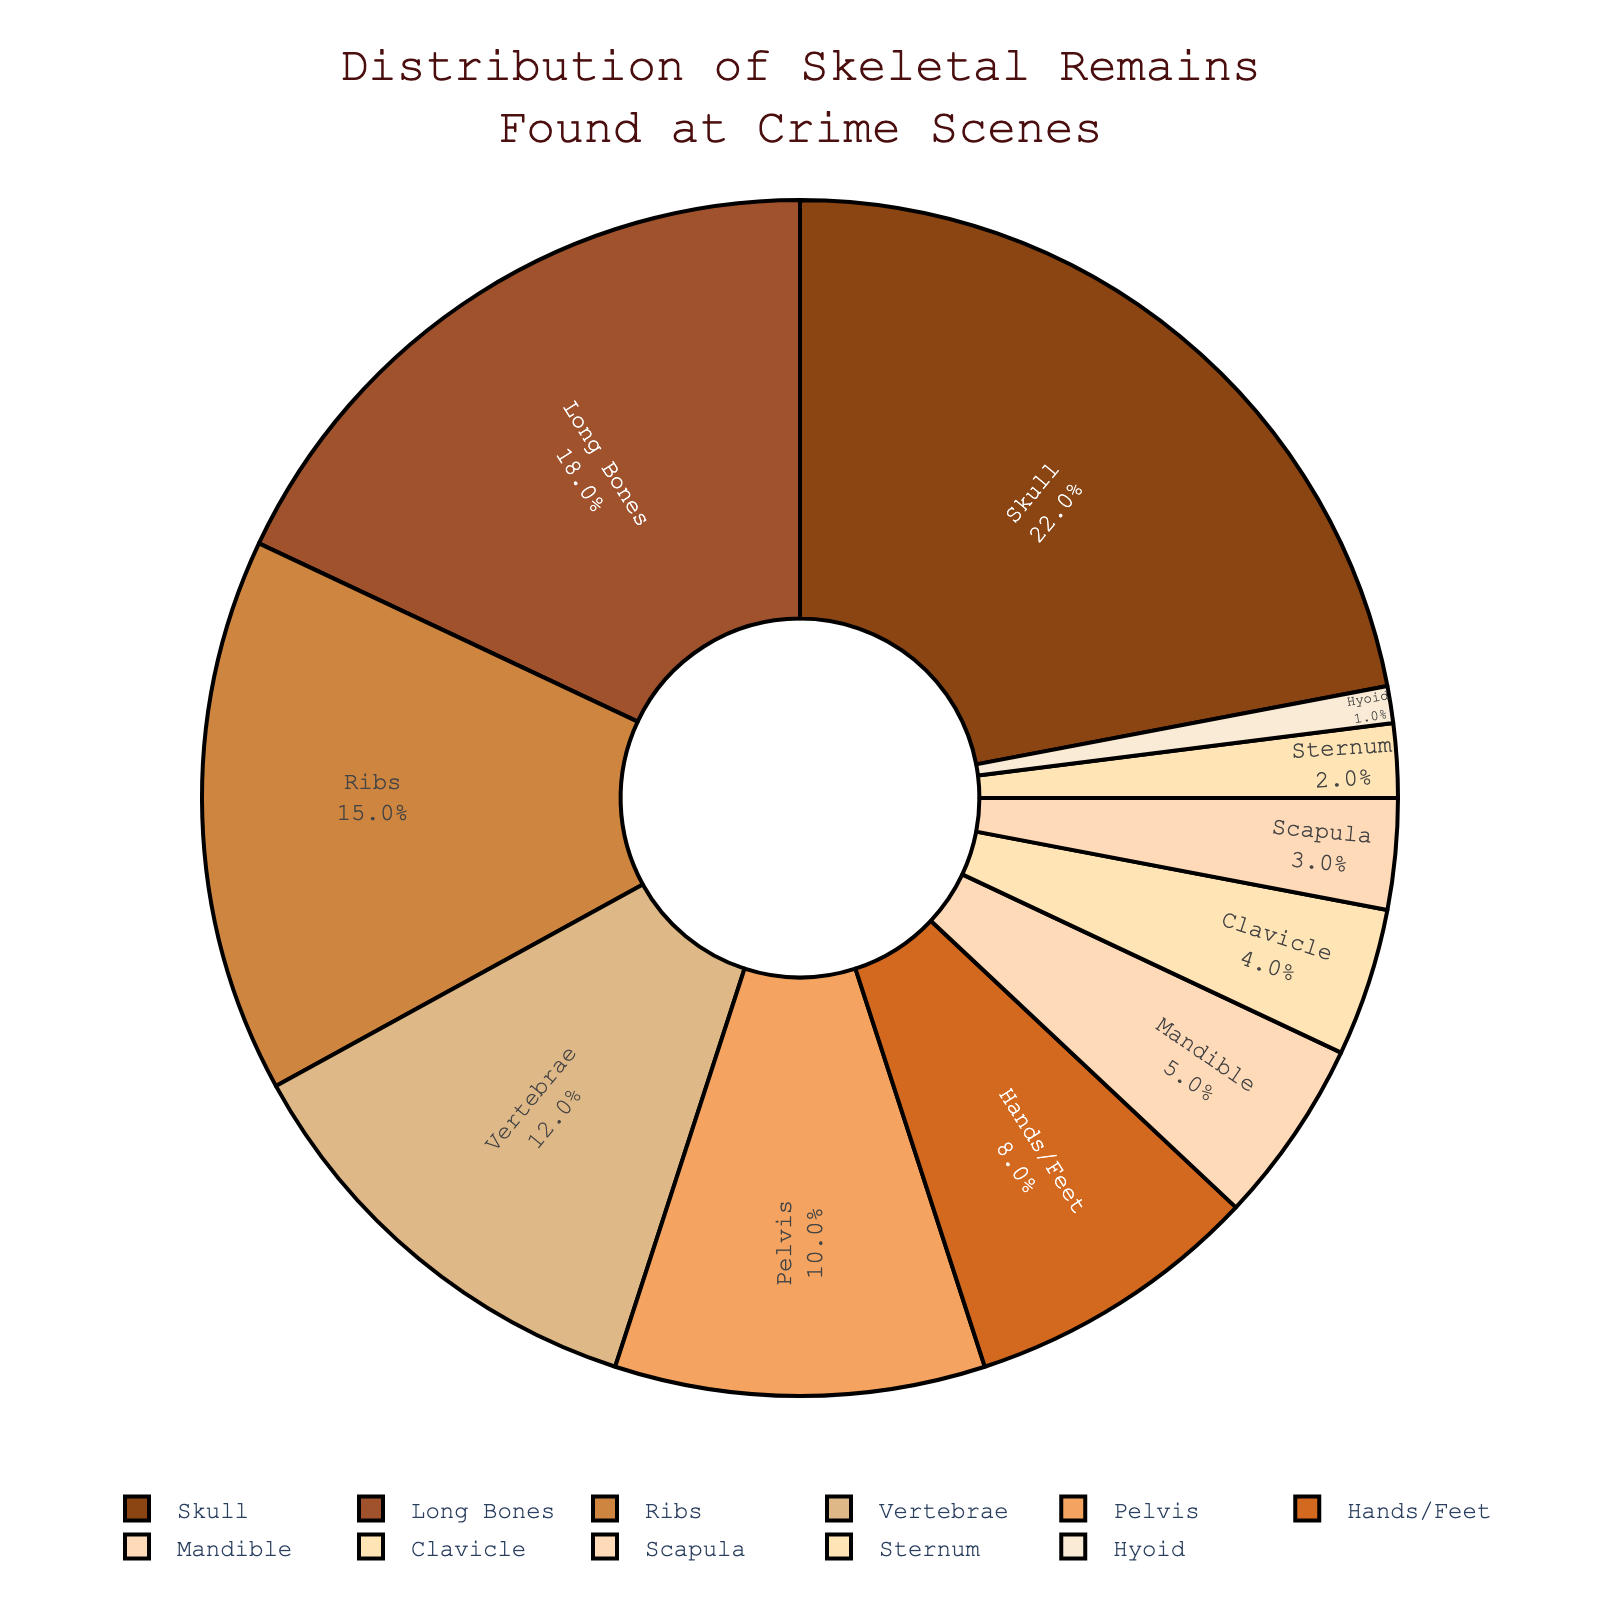what percentage of the skeletal remains found at crime scenes are skulls? The figure shows each body part and its corresponding percentage. According to the chart, skulls make up 22% of the skeletal remains found.
Answer: 22% which body part has the smallest percentage of skeletal remains found at crime scenes? By examining the pie chart, the smallest segment corresponds to the Hyoid, which has only 1% of the skeletal remains.
Answer: Hyoid what is the combined percentage of long bones and ribs found at crime scenes? To find the combined percentage, add the percentage of long bones (18%) to that of ribs (15%): 18% + 15% = 33%.
Answer: 33% are there more remains of vertebrae or pelvis found at crime scenes? Comparing the pie chart segments for vertebrae and pelvis, vertebrae have 12% while the pelvis has 10%. Therefore, vertebrae have a higher percentage.
Answer: Vertebrae which body parts together make up 50% of the skeletal remains found at crime scenes? Adding percentages from the largest down: skull (22%) + long bones (18%) + ribs (15%) = 55%, but since we only need 50%, the first two, skull and long bones, together make up 40%. Adding vertebrae (12%) next totals to 52%, so the correct combination is skull, long bones, and ribs = 22% + 18% + 15% = 55%, a little over 50%. A closer combination would be using skull (22%), long bones (18%), and pelvis (10%) = 50%.
Answer: Skull, long bones, and pelvis which body part has a percentage closest to 10% of the skeletal remains? According to the pie chart, the pelvis segment is closest to 10% of the skeletal remains found.
Answer: Pelvis how much greater is the percentage of skulls compared to the mandible? The percentage for skulls is 22% and for mandible is 5%. The difference is 22% - 5% = 17%.
Answer: 17% what is the combined percentage of skulls, long bones, and ribs? Adding the percentages of skulls (22%), long bones (18%), and ribs (15%): 22% + 18% + 15% = 55%.
Answer: 55% compare the percentage of skeletal remains found for the clavicle and scapula. The pie chart indicates that clavicle has 4%, and scapula has 3%. Therefore, the clavicle percentage is greater by 1%.
Answer: Clavicle by 1% how much do the percentages for hands/feet and mandible add up to? Add the percentages of hands/feet (8%) and mandible (5%): 8% + 5% = 13%.
Answer: 13% 